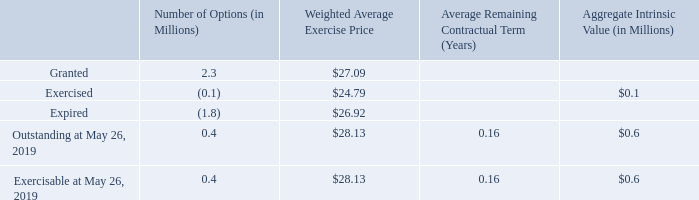Stock Appreciation Rights Awards
During the second quarter of fiscal 2019, in connection with the completion of the Pinnacle acquisition, we granted 2.3 million cash-settled stock appreciation rights with a fair value estimated at closing date using a Black-Scholes option-pricing model and a grant date price of $36.37 per share to Pinnacle employees in replacement of their unvested stock option awards that were outstanding as of the closing date. Approximately $14.8 million of the fair value of the replacement awards granted to Pinnacle employees was attributable to pre-combination service and was included in the purchase price and established as a liability. As of May 26, 2019, the liability of the replacement stock appreciation rights was $0.9 million, which includes post-combination service expense, the mark-to-market of the liability, and the impact of payouts since acquisition.
The compensation income for our cash-settled stock appreciation rights totaled $13.7 million for fiscal 2019. Included in this amount is income of $14.0 million related to the mark-to-market of the liability established in connection with the Pinnacle acquisition and expense of $0.2 million for accelerated vesting of awards related to Pinnacle integration restructuring activities, net of the impact of marking-to-market these awards based on a lower market price of Conagra common shares. The related tax expense for fiscal 2019 was $3.4 million.
A summary of the stock appreciation rights activity as of May 26, 2019 and changes during the fiscal year then ended is presented below:
How much was the total compensation income for cash-settled stock appreciation rights during fiscal 2019? $13.7 million. What is included in the liability of the replacement stock appreciation rights? Post-combination service expense, the mark-to-market of the liability, and the impact of payouts since acquisition. What was the total intrinsic value of exercisable stock appreciation rights during fiscal 2019?
Answer scale should be: million. $0.6. What is the total price of exercised and expired stocks?
Answer scale should be: million. (0.1*24.79)+(1.8*26.92) 
Answer: 50.94. What is the ratio of granted stocks to exercisable stocks? 2.3/0.4 
Answer: 5.75. What is the proportion of exercised and expired stocks over granted stocks? (0.1+1.8)/2.3 
Answer: 0.83. 